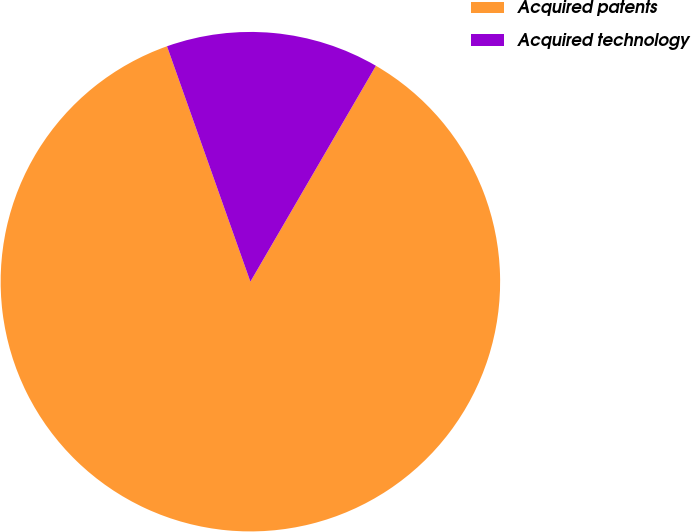<chart> <loc_0><loc_0><loc_500><loc_500><pie_chart><fcel>Acquired patents<fcel>Acquired technology<nl><fcel>86.2%<fcel>13.8%<nl></chart> 